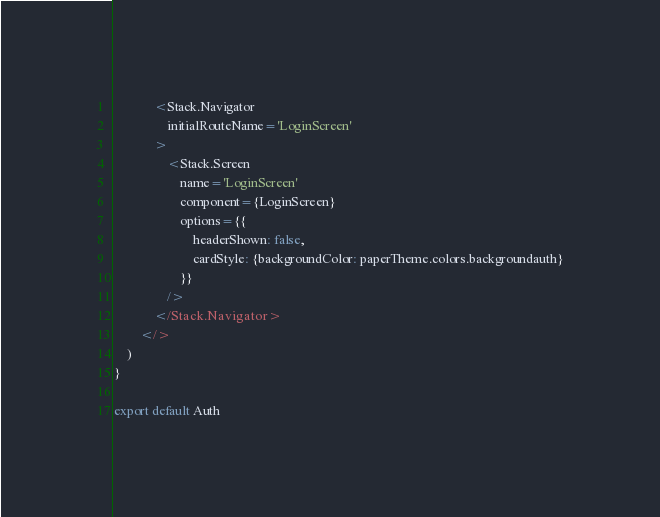Convert code to text. <code><loc_0><loc_0><loc_500><loc_500><_JavaScript_>            <Stack.Navigator
                initialRouteName='LoginScreen'
            >
                <Stack.Screen
                    name='LoginScreen'
                    component={LoginScreen}
                    options={{
                        headerShown: false,
                        cardStyle: {backgroundColor: paperTheme.colors.backgroundauth}
                    }}
                />
            </Stack.Navigator>
        </>
    )
}

export default Auth</code> 